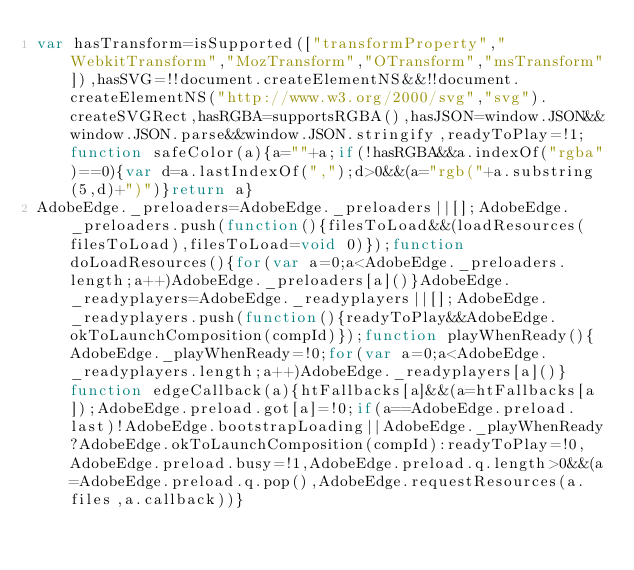Convert code to text. <code><loc_0><loc_0><loc_500><loc_500><_JavaScript_>var hasTransform=isSupported(["transformProperty","WebkitTransform","MozTransform","OTransform","msTransform"]),hasSVG=!!document.createElementNS&&!!document.createElementNS("http://www.w3.org/2000/svg","svg").createSVGRect,hasRGBA=supportsRGBA(),hasJSON=window.JSON&&window.JSON.parse&&window.JSON.stringify,readyToPlay=!1;function safeColor(a){a=""+a;if(!hasRGBA&&a.indexOf("rgba")==0){var d=a.lastIndexOf(",");d>0&&(a="rgb("+a.substring(5,d)+")")}return a}
AdobeEdge._preloaders=AdobeEdge._preloaders||[];AdobeEdge._preloaders.push(function(){filesToLoad&&(loadResources(filesToLoad),filesToLoad=void 0)});function doLoadResources(){for(var a=0;a<AdobeEdge._preloaders.length;a++)AdobeEdge._preloaders[a]()}AdobeEdge._readyplayers=AdobeEdge._readyplayers||[];AdobeEdge._readyplayers.push(function(){readyToPlay&&AdobeEdge.okToLaunchComposition(compId)});function playWhenReady(){AdobeEdge._playWhenReady=!0;for(var a=0;a<AdobeEdge._readyplayers.length;a++)AdobeEdge._readyplayers[a]()}function edgeCallback(a){htFallbacks[a]&&(a=htFallbacks[a]);AdobeEdge.preload.got[a]=!0;if(a==AdobeEdge.preload.last)!AdobeEdge.bootstrapLoading||AdobeEdge._playWhenReady?AdobeEdge.okToLaunchComposition(compId):readyToPlay=!0,AdobeEdge.preload.busy=!1,AdobeEdge.preload.q.length>0&&(a=AdobeEdge.preload.q.pop(),AdobeEdge.requestResources(a.files,a.callback))}</code> 